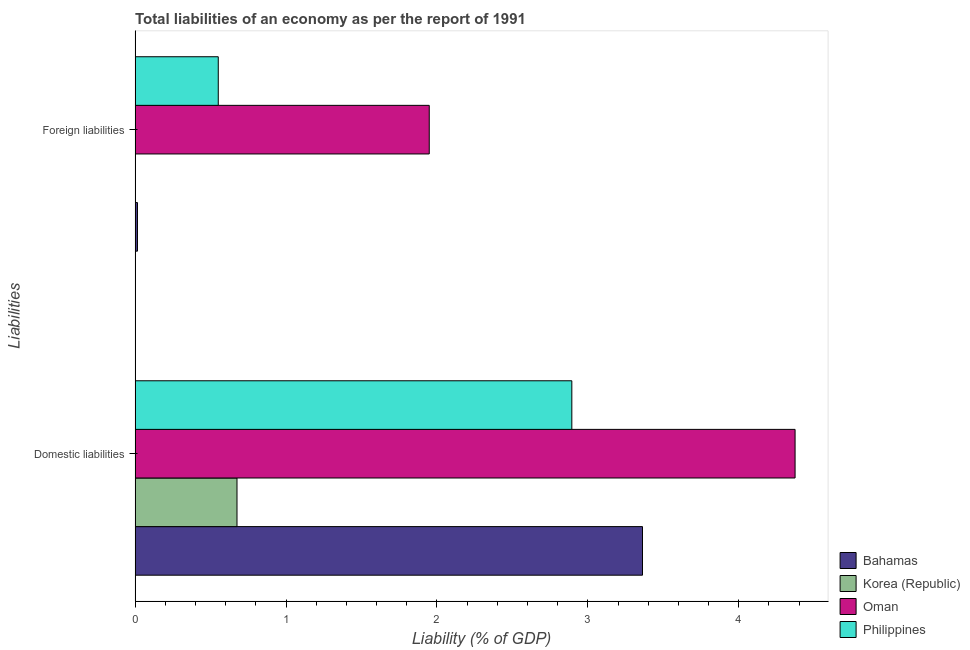How many different coloured bars are there?
Provide a succinct answer. 4. How many groups of bars are there?
Ensure brevity in your answer.  2. Are the number of bars on each tick of the Y-axis equal?
Your response must be concise. No. How many bars are there on the 2nd tick from the top?
Provide a succinct answer. 4. How many bars are there on the 1st tick from the bottom?
Offer a terse response. 4. What is the label of the 2nd group of bars from the top?
Ensure brevity in your answer.  Domestic liabilities. What is the incurrence of domestic liabilities in Philippines?
Provide a succinct answer. 2.89. Across all countries, what is the maximum incurrence of foreign liabilities?
Provide a succinct answer. 1.95. Across all countries, what is the minimum incurrence of domestic liabilities?
Offer a terse response. 0.68. In which country was the incurrence of domestic liabilities maximum?
Your response must be concise. Oman. What is the total incurrence of foreign liabilities in the graph?
Your answer should be very brief. 2.52. What is the difference between the incurrence of foreign liabilities in Bahamas and that in Oman?
Your answer should be compact. -1.93. What is the difference between the incurrence of foreign liabilities in Philippines and the incurrence of domestic liabilities in Korea (Republic)?
Your answer should be compact. -0.12. What is the average incurrence of domestic liabilities per country?
Give a very brief answer. 2.83. What is the difference between the incurrence of domestic liabilities and incurrence of foreign liabilities in Philippines?
Offer a terse response. 2.34. What is the ratio of the incurrence of domestic liabilities in Philippines to that in Oman?
Ensure brevity in your answer.  0.66. Is the incurrence of foreign liabilities in Philippines less than that in Bahamas?
Your answer should be compact. No. Are all the bars in the graph horizontal?
Offer a very short reply. Yes. What is the difference between two consecutive major ticks on the X-axis?
Offer a very short reply. 1. Are the values on the major ticks of X-axis written in scientific E-notation?
Your answer should be compact. No. How many legend labels are there?
Your answer should be very brief. 4. How are the legend labels stacked?
Your answer should be compact. Vertical. What is the title of the graph?
Provide a short and direct response. Total liabilities of an economy as per the report of 1991. Does "Netherlands" appear as one of the legend labels in the graph?
Your answer should be very brief. No. What is the label or title of the X-axis?
Offer a very short reply. Liability (% of GDP). What is the label or title of the Y-axis?
Make the answer very short. Liabilities. What is the Liability (% of GDP) in Bahamas in Domestic liabilities?
Keep it short and to the point. 3.36. What is the Liability (% of GDP) in Korea (Republic) in Domestic liabilities?
Ensure brevity in your answer.  0.68. What is the Liability (% of GDP) of Oman in Domestic liabilities?
Provide a succinct answer. 4.37. What is the Liability (% of GDP) of Philippines in Domestic liabilities?
Provide a short and direct response. 2.89. What is the Liability (% of GDP) of Bahamas in Foreign liabilities?
Your response must be concise. 0.02. What is the Liability (% of GDP) in Oman in Foreign liabilities?
Make the answer very short. 1.95. What is the Liability (% of GDP) of Philippines in Foreign liabilities?
Keep it short and to the point. 0.55. Across all Liabilities, what is the maximum Liability (% of GDP) in Bahamas?
Keep it short and to the point. 3.36. Across all Liabilities, what is the maximum Liability (% of GDP) of Korea (Republic)?
Your answer should be very brief. 0.68. Across all Liabilities, what is the maximum Liability (% of GDP) in Oman?
Offer a terse response. 4.37. Across all Liabilities, what is the maximum Liability (% of GDP) in Philippines?
Ensure brevity in your answer.  2.89. Across all Liabilities, what is the minimum Liability (% of GDP) in Bahamas?
Provide a succinct answer. 0.02. Across all Liabilities, what is the minimum Liability (% of GDP) of Korea (Republic)?
Provide a short and direct response. 0. Across all Liabilities, what is the minimum Liability (% of GDP) in Oman?
Keep it short and to the point. 1.95. Across all Liabilities, what is the minimum Liability (% of GDP) of Philippines?
Give a very brief answer. 0.55. What is the total Liability (% of GDP) in Bahamas in the graph?
Your response must be concise. 3.38. What is the total Liability (% of GDP) in Korea (Republic) in the graph?
Your response must be concise. 0.68. What is the total Liability (% of GDP) in Oman in the graph?
Offer a very short reply. 6.32. What is the total Liability (% of GDP) of Philippines in the graph?
Your answer should be compact. 3.45. What is the difference between the Liability (% of GDP) in Bahamas in Domestic liabilities and that in Foreign liabilities?
Your answer should be very brief. 3.35. What is the difference between the Liability (% of GDP) in Oman in Domestic liabilities and that in Foreign liabilities?
Make the answer very short. 2.42. What is the difference between the Liability (% of GDP) of Philippines in Domestic liabilities and that in Foreign liabilities?
Offer a terse response. 2.34. What is the difference between the Liability (% of GDP) in Bahamas in Domestic liabilities and the Liability (% of GDP) in Oman in Foreign liabilities?
Offer a very short reply. 1.41. What is the difference between the Liability (% of GDP) of Bahamas in Domestic liabilities and the Liability (% of GDP) of Philippines in Foreign liabilities?
Provide a short and direct response. 2.81. What is the difference between the Liability (% of GDP) of Korea (Republic) in Domestic liabilities and the Liability (% of GDP) of Oman in Foreign liabilities?
Provide a succinct answer. -1.27. What is the difference between the Liability (% of GDP) in Korea (Republic) in Domestic liabilities and the Liability (% of GDP) in Philippines in Foreign liabilities?
Give a very brief answer. 0.12. What is the difference between the Liability (% of GDP) in Oman in Domestic liabilities and the Liability (% of GDP) in Philippines in Foreign liabilities?
Your answer should be compact. 3.82. What is the average Liability (% of GDP) of Bahamas per Liabilities?
Ensure brevity in your answer.  1.69. What is the average Liability (% of GDP) in Korea (Republic) per Liabilities?
Offer a very short reply. 0.34. What is the average Liability (% of GDP) in Oman per Liabilities?
Offer a very short reply. 3.16. What is the average Liability (% of GDP) of Philippines per Liabilities?
Give a very brief answer. 1.72. What is the difference between the Liability (% of GDP) in Bahamas and Liability (% of GDP) in Korea (Republic) in Domestic liabilities?
Offer a very short reply. 2.69. What is the difference between the Liability (% of GDP) of Bahamas and Liability (% of GDP) of Oman in Domestic liabilities?
Provide a succinct answer. -1.01. What is the difference between the Liability (% of GDP) of Bahamas and Liability (% of GDP) of Philippines in Domestic liabilities?
Your answer should be very brief. 0.47. What is the difference between the Liability (% of GDP) of Korea (Republic) and Liability (% of GDP) of Oman in Domestic liabilities?
Your answer should be compact. -3.7. What is the difference between the Liability (% of GDP) of Korea (Republic) and Liability (% of GDP) of Philippines in Domestic liabilities?
Offer a very short reply. -2.22. What is the difference between the Liability (% of GDP) in Oman and Liability (% of GDP) in Philippines in Domestic liabilities?
Ensure brevity in your answer.  1.48. What is the difference between the Liability (% of GDP) in Bahamas and Liability (% of GDP) in Oman in Foreign liabilities?
Give a very brief answer. -1.93. What is the difference between the Liability (% of GDP) of Bahamas and Liability (% of GDP) of Philippines in Foreign liabilities?
Provide a succinct answer. -0.54. What is the difference between the Liability (% of GDP) in Oman and Liability (% of GDP) in Philippines in Foreign liabilities?
Provide a short and direct response. 1.4. What is the ratio of the Liability (% of GDP) in Bahamas in Domestic liabilities to that in Foreign liabilities?
Make the answer very short. 209.2. What is the ratio of the Liability (% of GDP) of Oman in Domestic liabilities to that in Foreign liabilities?
Your answer should be very brief. 2.24. What is the ratio of the Liability (% of GDP) in Philippines in Domestic liabilities to that in Foreign liabilities?
Keep it short and to the point. 5.25. What is the difference between the highest and the second highest Liability (% of GDP) of Bahamas?
Offer a terse response. 3.35. What is the difference between the highest and the second highest Liability (% of GDP) of Oman?
Give a very brief answer. 2.42. What is the difference between the highest and the second highest Liability (% of GDP) in Philippines?
Ensure brevity in your answer.  2.34. What is the difference between the highest and the lowest Liability (% of GDP) of Bahamas?
Provide a short and direct response. 3.35. What is the difference between the highest and the lowest Liability (% of GDP) of Korea (Republic)?
Make the answer very short. 0.68. What is the difference between the highest and the lowest Liability (% of GDP) of Oman?
Ensure brevity in your answer.  2.42. What is the difference between the highest and the lowest Liability (% of GDP) in Philippines?
Keep it short and to the point. 2.34. 